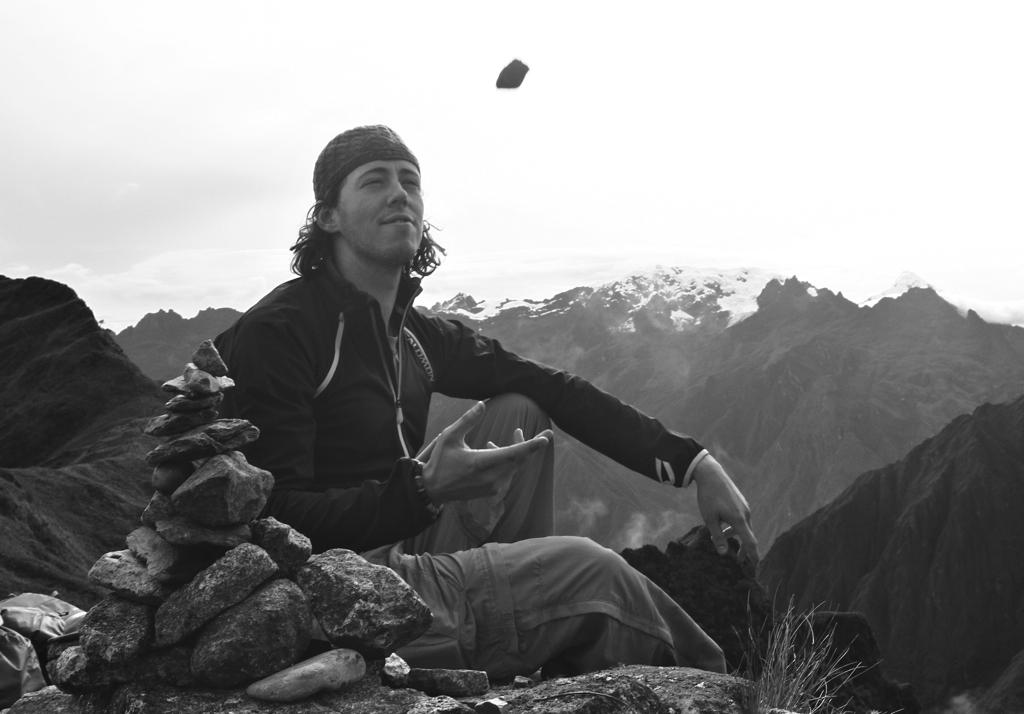What is the color scheme of the image? The image is black and white. What is the person in the image doing? The person is sitting on a rock in the image. What type of objects can be seen on the ground in the image? There are stones in the image. What type of natural landscape is visible in the image? There are mountains in the image. What is visible in the background of the image? The sky is visible in the image. Can you tell me how many receipts are lying on the ground in the image? There are no receipts present in the image; it features a person sitting on a rock with stones and mountains in the background. What type of truck can be seen driving through the mountains in the image? There is no truck visible in the image; it is a black and white image of a person sitting on a rock with stones and mountains in the background. 